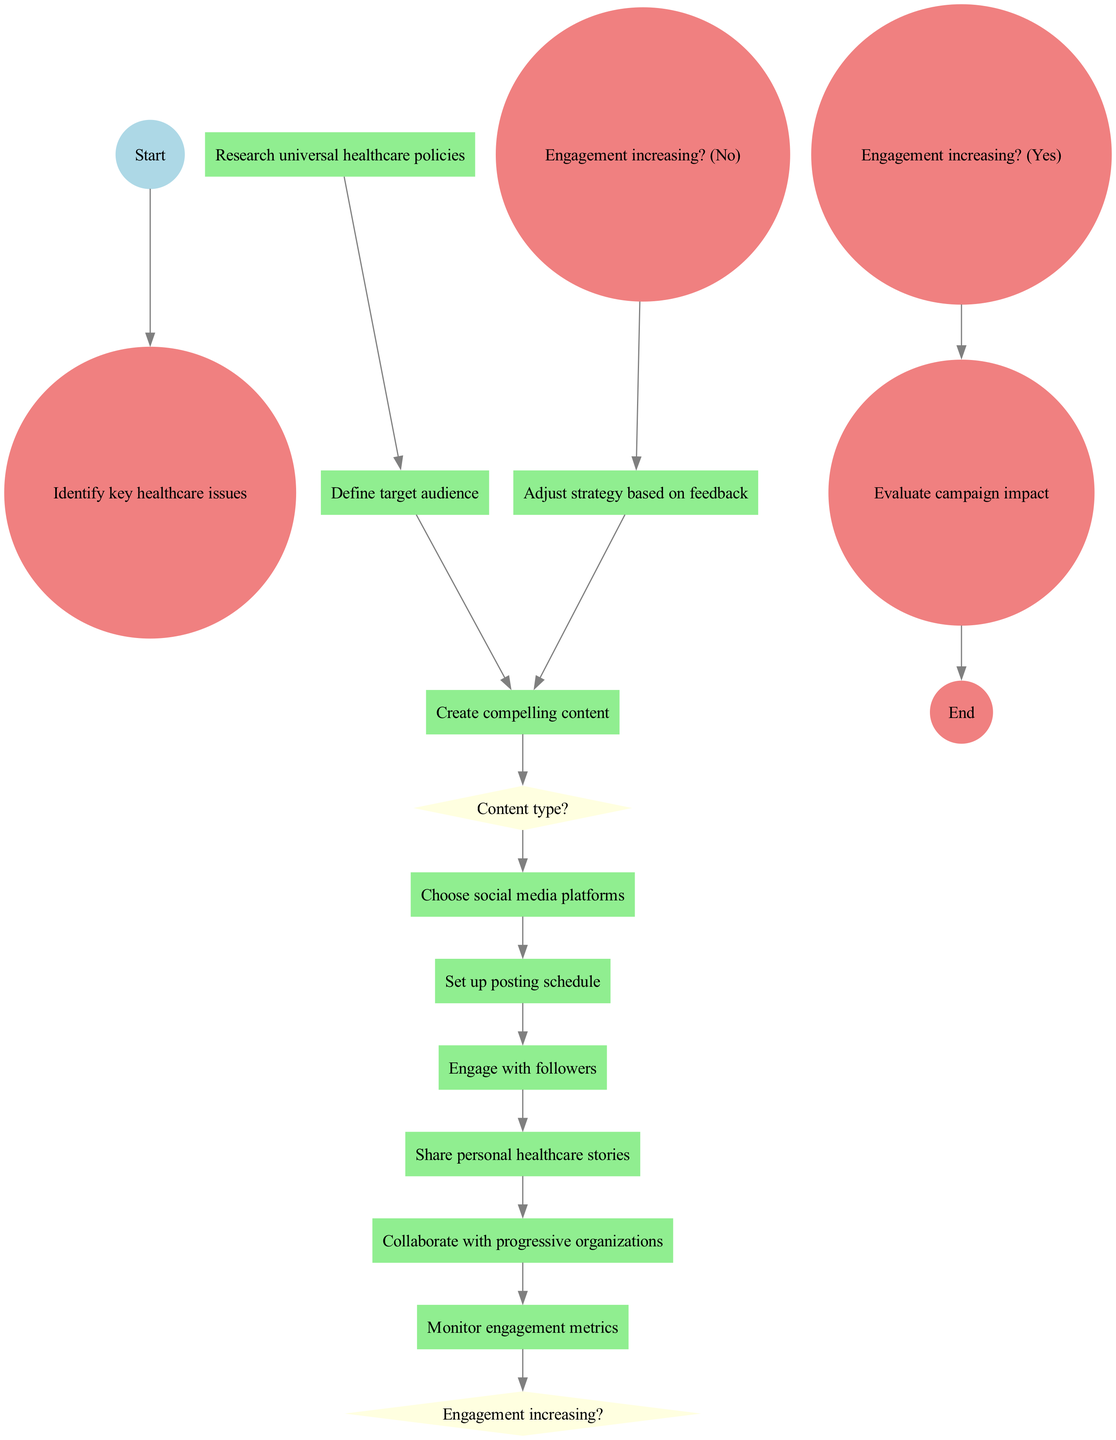What is the starting node of the diagram? The starting node, as explicitly defined in the diagram, is "Identify key healthcare issues."
Answer: Identify key healthcare issues How many activities are present in the diagram? By counting each listed activity in the activities section, we find there are ten distinct activities.
Answer: 10 What action follows "Share personal healthcare stories"? The action following "Share personal healthcare stories" leads to "Collaborate with progressive organizations."
Answer: Collaborate with progressive organizations If the engagement is increasing, what is the next action? If "Engagement increasing?" is answered with "Yes," the flow moves to "Evaluate campaign impact."
Answer: Evaluate campaign impact What are the options for the decision "Content type?" The options provided for "Content type?" include "Infographics," "Articles," and "Videos."
Answer: Infographics, Articles, Videos Which activity comes directly after "Set up posting schedule"? The activity that comes directly after "Set up posting schedule" is "Engage with followers."
Answer: Engage with followers What happens when the engagement is not increasing? When engagement is not increasing, the strategy needs to be "Adjusted based on feedback."
Answer: Adjust strategy based on feedback How does one move from "Create compelling content" to "Choose social media platforms"? After "Create compelling content," the flow progresses directly to "Choose social media platforms."
Answer: Choose social media platforms What is the end node of the diagram? The end node specified in the diagram is "Evaluate campaign impact."
Answer: Evaluate campaign impact 